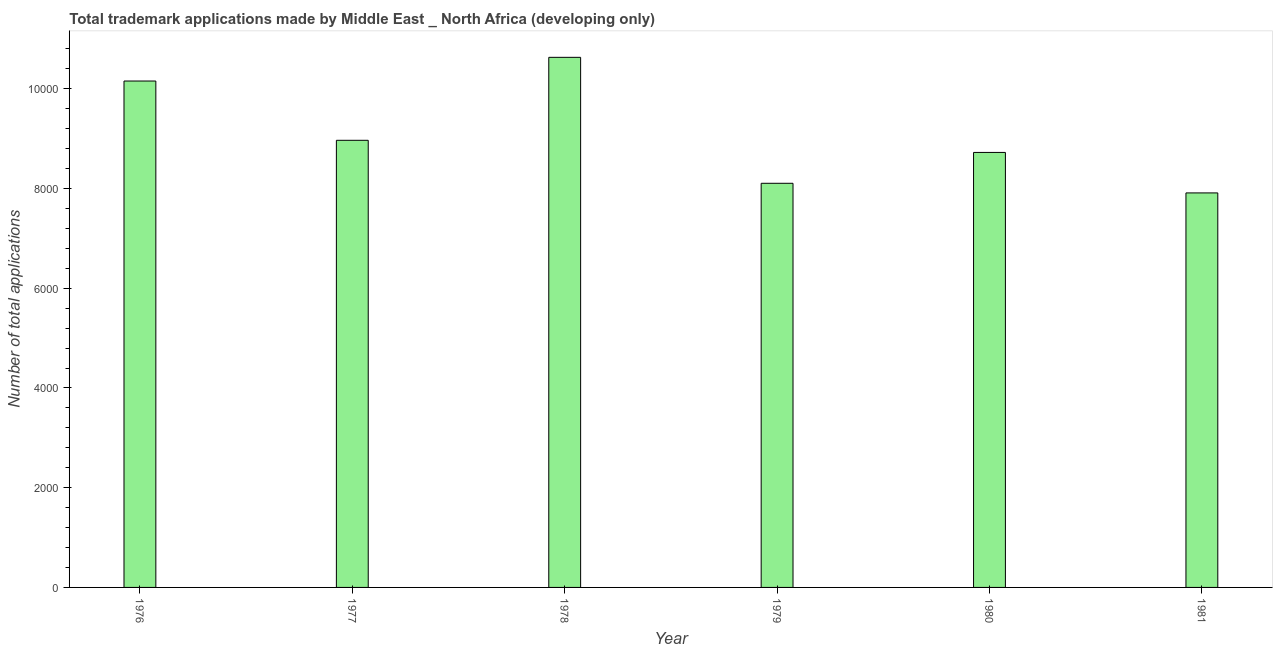Does the graph contain any zero values?
Ensure brevity in your answer.  No. What is the title of the graph?
Your answer should be very brief. Total trademark applications made by Middle East _ North Africa (developing only). What is the label or title of the X-axis?
Your answer should be compact. Year. What is the label or title of the Y-axis?
Offer a terse response. Number of total applications. What is the number of trademark applications in 1978?
Offer a very short reply. 1.06e+04. Across all years, what is the maximum number of trademark applications?
Your answer should be compact. 1.06e+04. Across all years, what is the minimum number of trademark applications?
Offer a very short reply. 7911. In which year was the number of trademark applications maximum?
Your answer should be compact. 1978. In which year was the number of trademark applications minimum?
Offer a terse response. 1981. What is the sum of the number of trademark applications?
Provide a succinct answer. 5.45e+04. What is the difference between the number of trademark applications in 1978 and 1981?
Your answer should be very brief. 2719. What is the average number of trademark applications per year?
Provide a succinct answer. 9081. What is the median number of trademark applications?
Provide a succinct answer. 8844.5. In how many years, is the number of trademark applications greater than 5600 ?
Offer a terse response. 6. What is the ratio of the number of trademark applications in 1979 to that in 1981?
Offer a very short reply. 1.02. Is the number of trademark applications in 1977 less than that in 1978?
Offer a terse response. Yes. What is the difference between the highest and the second highest number of trademark applications?
Keep it short and to the point. 475. Is the sum of the number of trademark applications in 1980 and 1981 greater than the maximum number of trademark applications across all years?
Your answer should be compact. Yes. What is the difference between the highest and the lowest number of trademark applications?
Your response must be concise. 2719. Are all the bars in the graph horizontal?
Provide a succinct answer. No. How many years are there in the graph?
Make the answer very short. 6. Are the values on the major ticks of Y-axis written in scientific E-notation?
Keep it short and to the point. No. What is the Number of total applications in 1976?
Offer a very short reply. 1.02e+04. What is the Number of total applications of 1977?
Your response must be concise. 8966. What is the Number of total applications in 1978?
Ensure brevity in your answer.  1.06e+04. What is the Number of total applications of 1979?
Your response must be concise. 8104. What is the Number of total applications of 1980?
Offer a terse response. 8723. What is the Number of total applications in 1981?
Your answer should be very brief. 7911. What is the difference between the Number of total applications in 1976 and 1977?
Your answer should be very brief. 1189. What is the difference between the Number of total applications in 1976 and 1978?
Your answer should be compact. -475. What is the difference between the Number of total applications in 1976 and 1979?
Your response must be concise. 2051. What is the difference between the Number of total applications in 1976 and 1980?
Ensure brevity in your answer.  1432. What is the difference between the Number of total applications in 1976 and 1981?
Keep it short and to the point. 2244. What is the difference between the Number of total applications in 1977 and 1978?
Your answer should be compact. -1664. What is the difference between the Number of total applications in 1977 and 1979?
Offer a very short reply. 862. What is the difference between the Number of total applications in 1977 and 1980?
Your response must be concise. 243. What is the difference between the Number of total applications in 1977 and 1981?
Give a very brief answer. 1055. What is the difference between the Number of total applications in 1978 and 1979?
Make the answer very short. 2526. What is the difference between the Number of total applications in 1978 and 1980?
Offer a terse response. 1907. What is the difference between the Number of total applications in 1978 and 1981?
Give a very brief answer. 2719. What is the difference between the Number of total applications in 1979 and 1980?
Give a very brief answer. -619. What is the difference between the Number of total applications in 1979 and 1981?
Give a very brief answer. 193. What is the difference between the Number of total applications in 1980 and 1981?
Offer a terse response. 812. What is the ratio of the Number of total applications in 1976 to that in 1977?
Make the answer very short. 1.13. What is the ratio of the Number of total applications in 1976 to that in 1978?
Your answer should be compact. 0.95. What is the ratio of the Number of total applications in 1976 to that in 1979?
Make the answer very short. 1.25. What is the ratio of the Number of total applications in 1976 to that in 1980?
Keep it short and to the point. 1.16. What is the ratio of the Number of total applications in 1976 to that in 1981?
Keep it short and to the point. 1.28. What is the ratio of the Number of total applications in 1977 to that in 1978?
Offer a very short reply. 0.84. What is the ratio of the Number of total applications in 1977 to that in 1979?
Keep it short and to the point. 1.11. What is the ratio of the Number of total applications in 1977 to that in 1980?
Your answer should be compact. 1.03. What is the ratio of the Number of total applications in 1977 to that in 1981?
Provide a short and direct response. 1.13. What is the ratio of the Number of total applications in 1978 to that in 1979?
Make the answer very short. 1.31. What is the ratio of the Number of total applications in 1978 to that in 1980?
Your response must be concise. 1.22. What is the ratio of the Number of total applications in 1978 to that in 1981?
Offer a terse response. 1.34. What is the ratio of the Number of total applications in 1979 to that in 1980?
Offer a terse response. 0.93. What is the ratio of the Number of total applications in 1979 to that in 1981?
Offer a terse response. 1.02. What is the ratio of the Number of total applications in 1980 to that in 1981?
Ensure brevity in your answer.  1.1. 